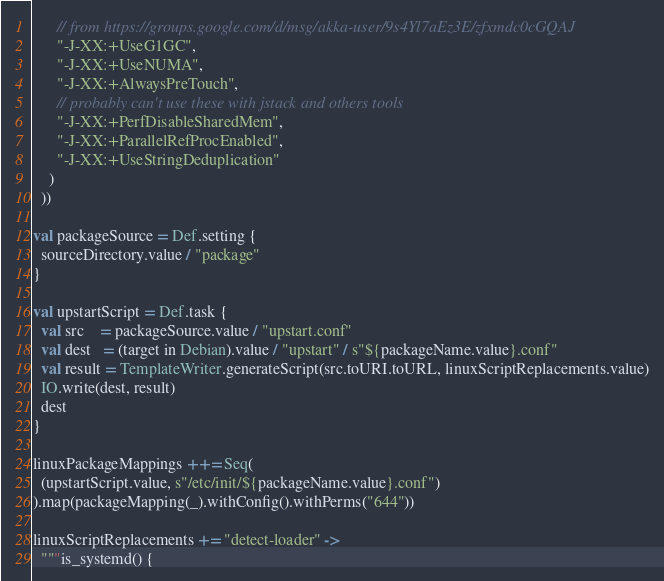Convert code to text. <code><loc_0><loc_0><loc_500><loc_500><_Scala_>      // from https://groups.google.com/d/msg/akka-user/9s4Yl7aEz3E/zfxmdc0cGQAJ
      "-J-XX:+UseG1GC",
      "-J-XX:+UseNUMA",
      "-J-XX:+AlwaysPreTouch",
      // probably can't use these with jstack and others tools
      "-J-XX:+PerfDisableSharedMem",
      "-J-XX:+ParallelRefProcEnabled",
      "-J-XX:+UseStringDeduplication"
    )
  ))

val packageSource = Def.setting {
  sourceDirectory.value / "package"
}

val upstartScript = Def.task {
  val src    = packageSource.value / "upstart.conf"
  val dest   = (target in Debian).value / "upstart" / s"${packageName.value}.conf"
  val result = TemplateWriter.generateScript(src.toURI.toURL, linuxScriptReplacements.value)
  IO.write(dest, result)
  dest
}

linuxPackageMappings ++= Seq(
  (upstartScript.value, s"/etc/init/${packageName.value}.conf")
).map(packageMapping(_).withConfig().withPerms("644"))

linuxScriptReplacements += "detect-loader" ->
  """is_systemd() {</code> 